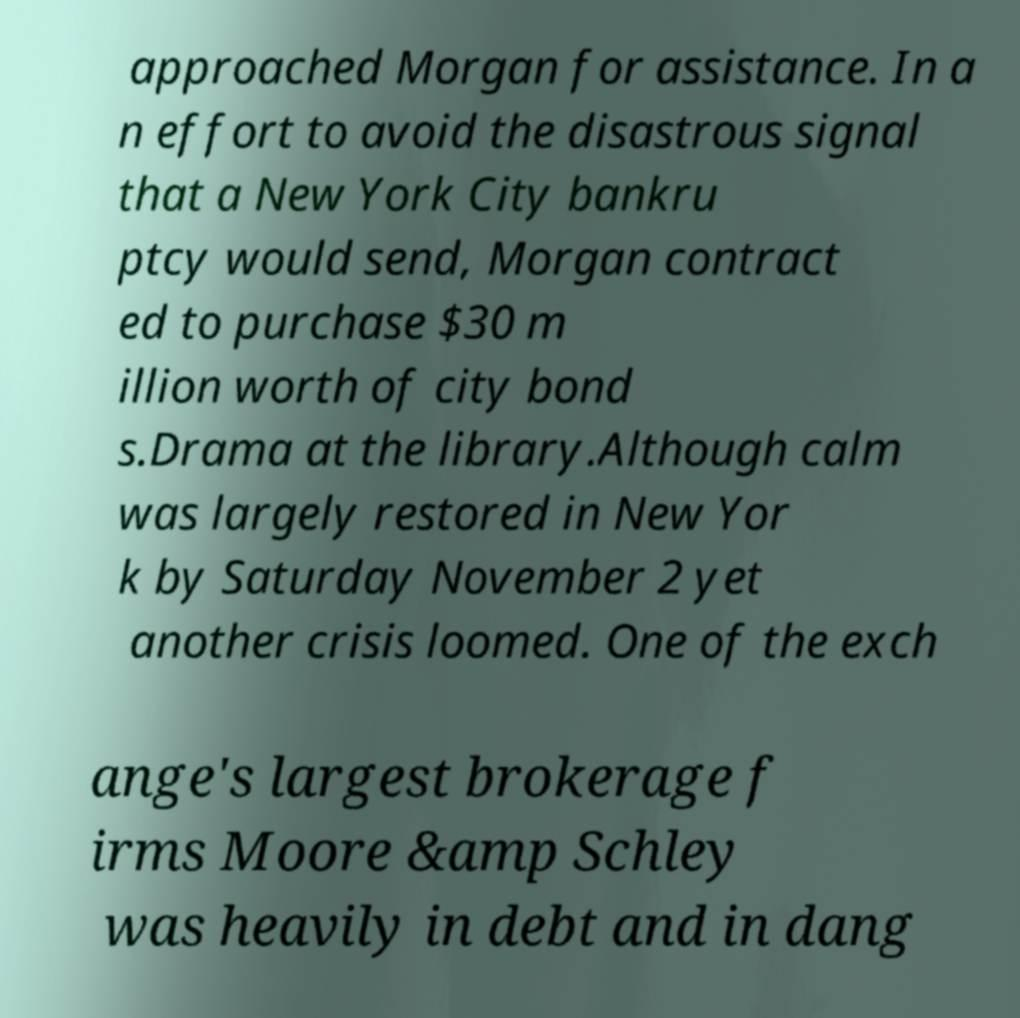For documentation purposes, I need the text within this image transcribed. Could you provide that? approached Morgan for assistance. In a n effort to avoid the disastrous signal that a New York City bankru ptcy would send, Morgan contract ed to purchase $30 m illion worth of city bond s.Drama at the library.Although calm was largely restored in New Yor k by Saturday November 2 yet another crisis loomed. One of the exch ange's largest brokerage f irms Moore &amp Schley was heavily in debt and in dang 